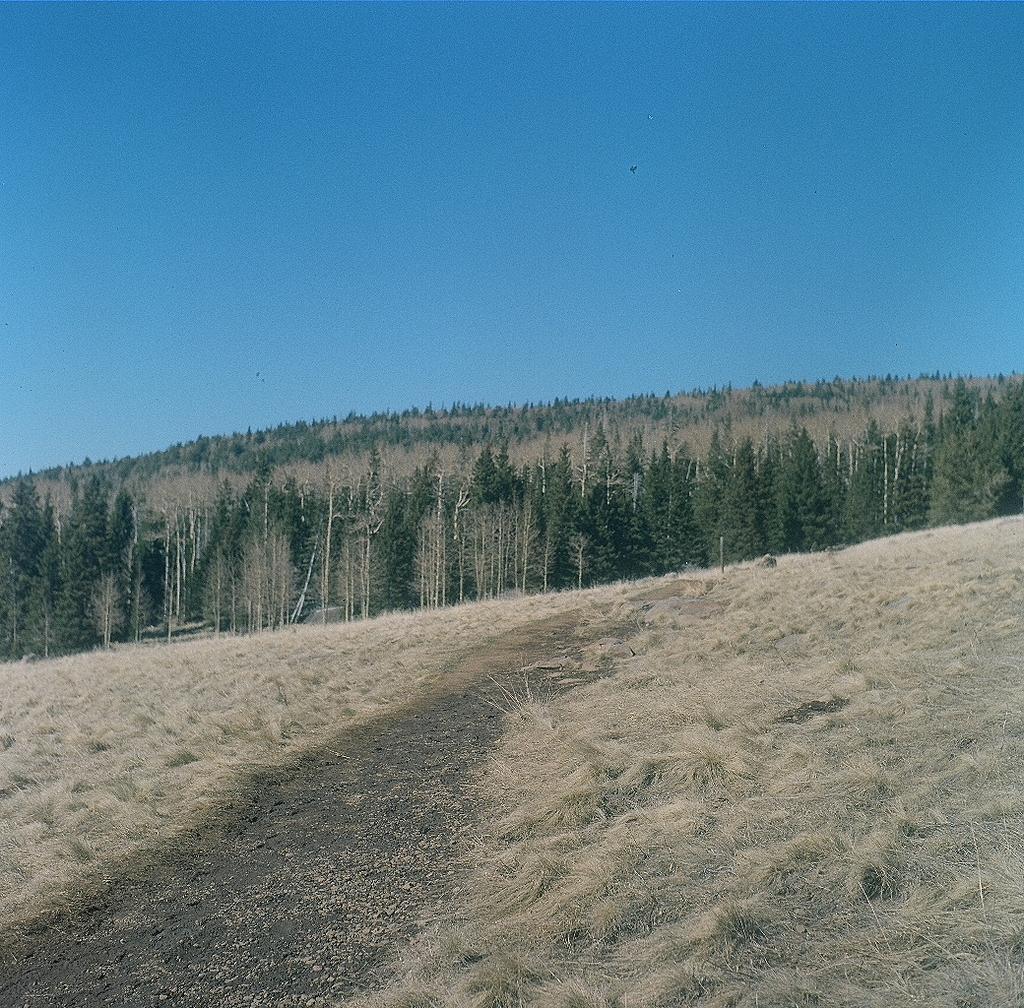Please provide a concise description of this image. There is a grassy land at the bottom of this image. We can see trees in the background and the blue sky is at the top of this image. 